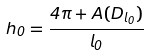<formula> <loc_0><loc_0><loc_500><loc_500>h _ { 0 } = \frac { 4 \pi + A ( D _ { l _ { 0 } } ) } { l _ { 0 } }</formula> 